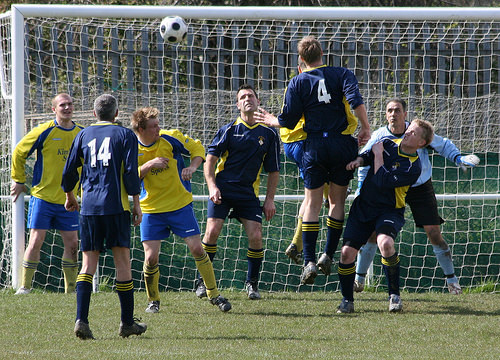<image>
Can you confirm if the man is next to the man? No. The man is not positioned next to the man. They are located in different areas of the scene. Is there a player in front of the ball? Yes. The player is positioned in front of the ball, appearing closer to the camera viewpoint. Where is the shoes in relation to the grass? Is it above the grass? Yes. The shoes is positioned above the grass in the vertical space, higher up in the scene. 